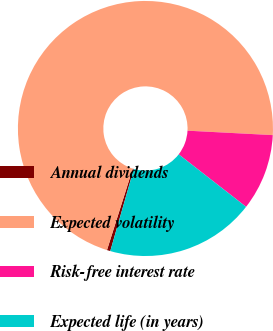<chart> <loc_0><loc_0><loc_500><loc_500><pie_chart><fcel>Annual dividends<fcel>Expected volatility<fcel>Risk-free interest rate<fcel>Expected life (in years)<nl><fcel>0.43%<fcel>70.96%<fcel>9.7%<fcel>18.92%<nl></chart> 